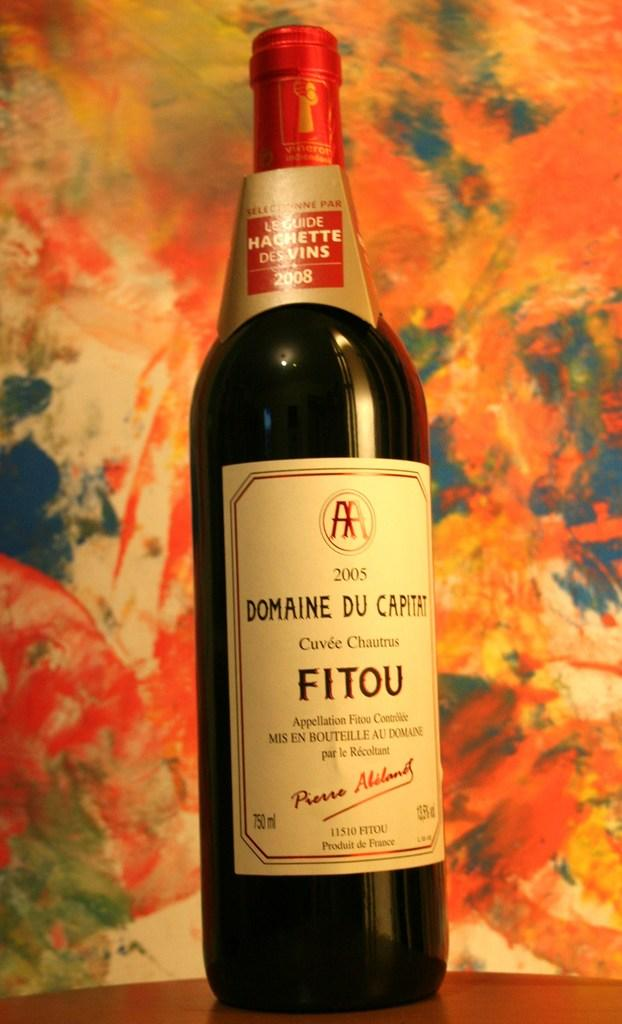Provide a one-sentence caption for the provided image. A bottle of Domaine Du Capitat is in front of a very colorful wall. 